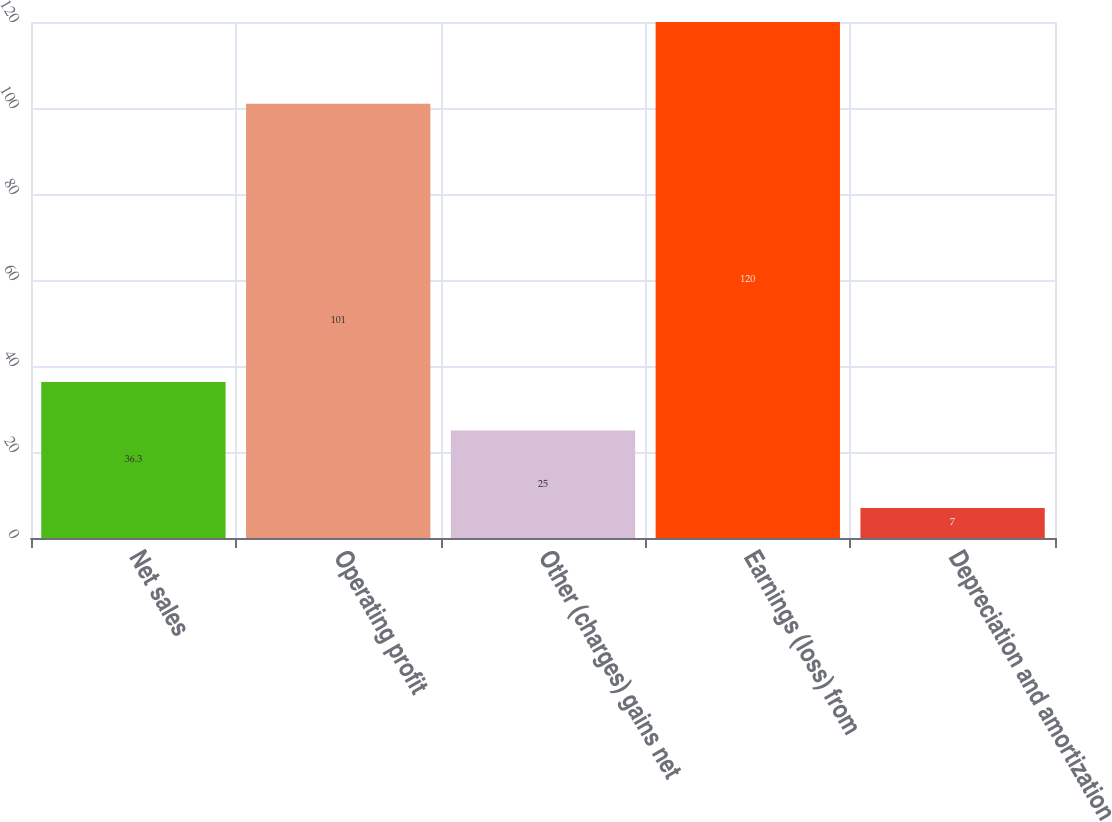Convert chart. <chart><loc_0><loc_0><loc_500><loc_500><bar_chart><fcel>Net sales<fcel>Operating profit<fcel>Other (charges) gains net<fcel>Earnings (loss) from<fcel>Depreciation and amortization<nl><fcel>36.3<fcel>101<fcel>25<fcel>120<fcel>7<nl></chart> 